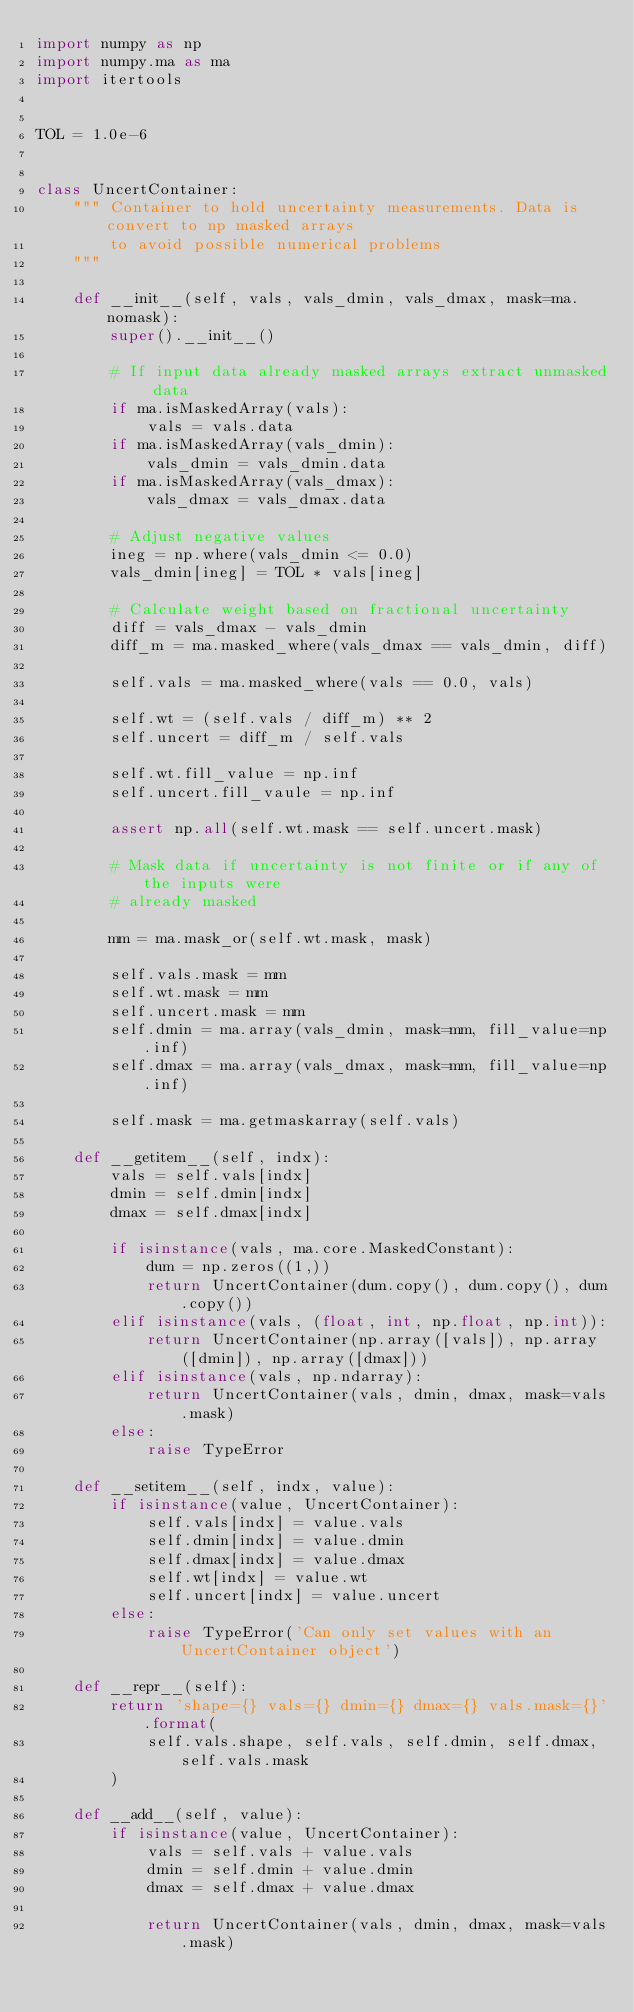<code> <loc_0><loc_0><loc_500><loc_500><_Python_>import numpy as np
import numpy.ma as ma
import itertools


TOL = 1.0e-6


class UncertContainer:
    """ Container to hold uncertainty measurements. Data is convert to np masked arrays
        to avoid possible numerical problems
    """

    def __init__(self, vals, vals_dmin, vals_dmax, mask=ma.nomask):
        super().__init__()

        # If input data already masked arrays extract unmasked data
        if ma.isMaskedArray(vals):
            vals = vals.data
        if ma.isMaskedArray(vals_dmin):
            vals_dmin = vals_dmin.data
        if ma.isMaskedArray(vals_dmax):
            vals_dmax = vals_dmax.data

        # Adjust negative values
        ineg = np.where(vals_dmin <= 0.0)
        vals_dmin[ineg] = TOL * vals[ineg]

        # Calculate weight based on fractional uncertainty
        diff = vals_dmax - vals_dmin
        diff_m = ma.masked_where(vals_dmax == vals_dmin, diff)

        self.vals = ma.masked_where(vals == 0.0, vals)

        self.wt = (self.vals / diff_m) ** 2
        self.uncert = diff_m / self.vals

        self.wt.fill_value = np.inf
        self.uncert.fill_vaule = np.inf

        assert np.all(self.wt.mask == self.uncert.mask)

        # Mask data if uncertainty is not finite or if any of the inputs were
        # already masked

        mm = ma.mask_or(self.wt.mask, mask)

        self.vals.mask = mm
        self.wt.mask = mm
        self.uncert.mask = mm
        self.dmin = ma.array(vals_dmin, mask=mm, fill_value=np.inf)
        self.dmax = ma.array(vals_dmax, mask=mm, fill_value=np.inf)

        self.mask = ma.getmaskarray(self.vals)

    def __getitem__(self, indx):
        vals = self.vals[indx]
        dmin = self.dmin[indx]
        dmax = self.dmax[indx]

        if isinstance(vals, ma.core.MaskedConstant):
            dum = np.zeros((1,))
            return UncertContainer(dum.copy(), dum.copy(), dum.copy())
        elif isinstance(vals, (float, int, np.float, np.int)):
            return UncertContainer(np.array([vals]), np.array([dmin]), np.array([dmax]))
        elif isinstance(vals, np.ndarray):
            return UncertContainer(vals, dmin, dmax, mask=vals.mask)
        else:
            raise TypeError

    def __setitem__(self, indx, value):
        if isinstance(value, UncertContainer):
            self.vals[indx] = value.vals
            self.dmin[indx] = value.dmin
            self.dmax[indx] = value.dmax
            self.wt[indx] = value.wt
            self.uncert[indx] = value.uncert
        else:
            raise TypeError('Can only set values with an UncertContainer object')

    def __repr__(self):
        return 'shape={} vals={} dmin={} dmax={} vals.mask={}'.format(
            self.vals.shape, self.vals, self.dmin, self.dmax, self.vals.mask
        )

    def __add__(self, value):
        if isinstance(value, UncertContainer):
            vals = self.vals + value.vals
            dmin = self.dmin + value.dmin
            dmax = self.dmax + value.dmax

            return UncertContainer(vals, dmin, dmax, mask=vals.mask)</code> 